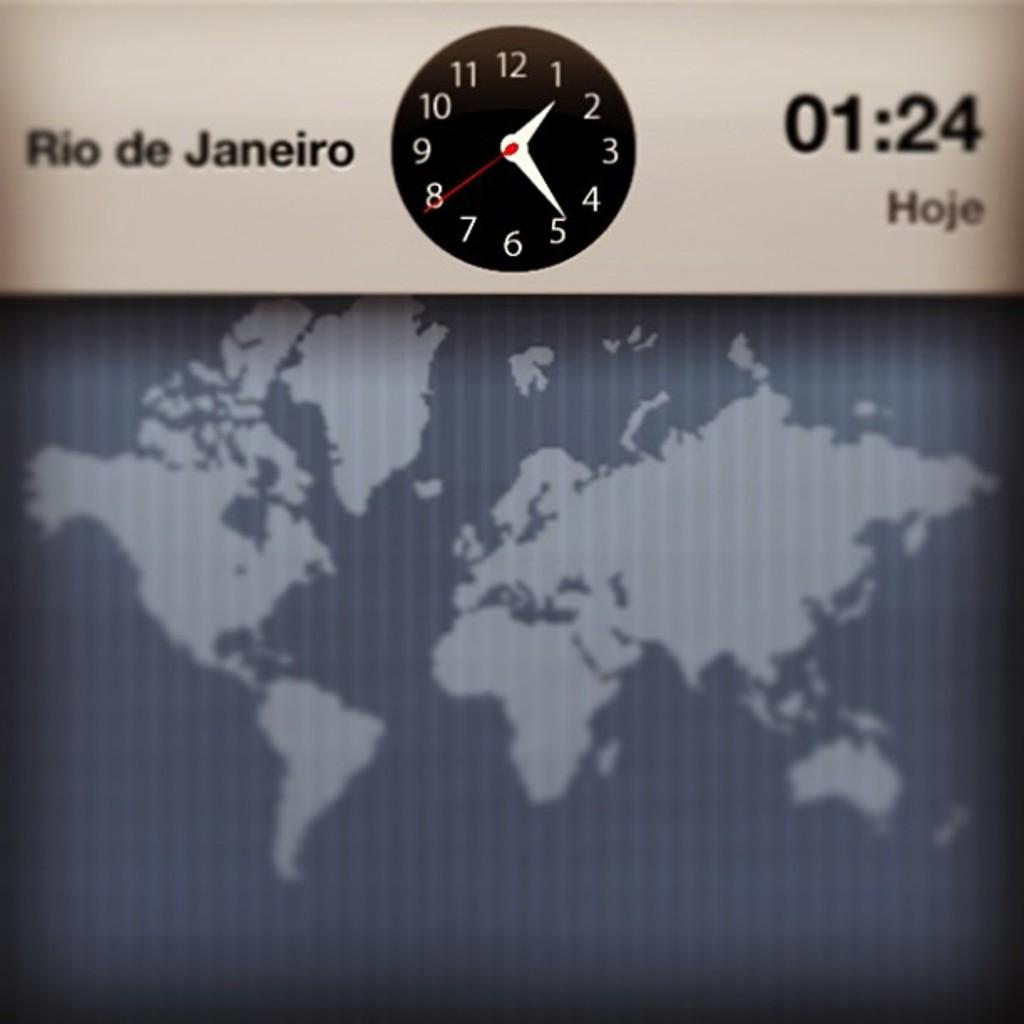Provide a one-sentence caption for the provided image. A clock displaying the time in Rio de Janeiro of 1:24. 